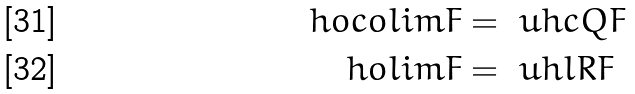Convert formula to latex. <formula><loc_0><loc_0><loc_500><loc_500>\ h o c o l i m F & = \ u h c Q F \\ \ h o l i m F & = \ u h l R F</formula> 